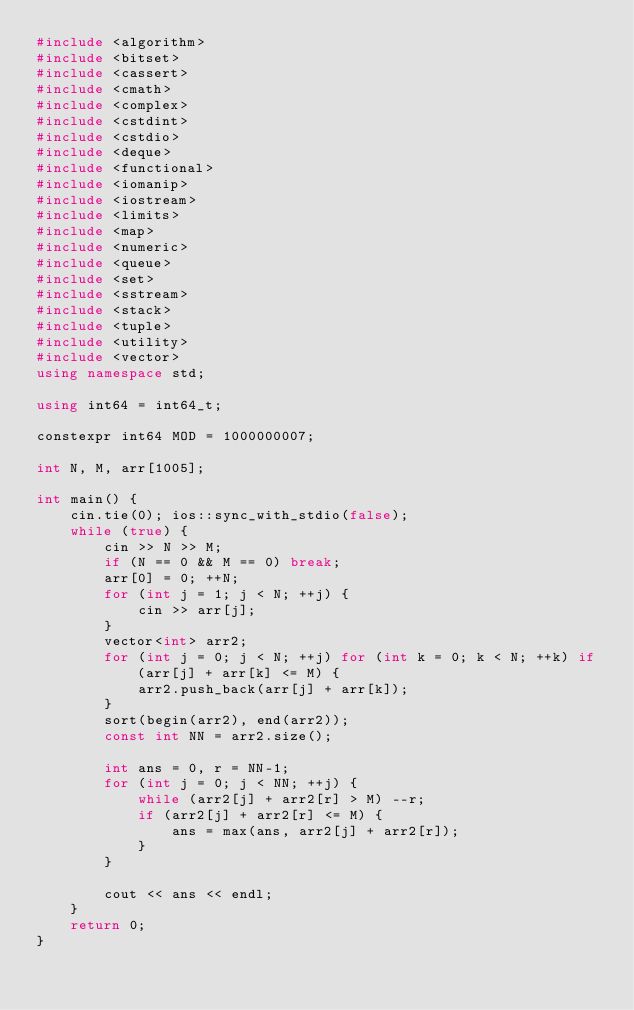Convert code to text. <code><loc_0><loc_0><loc_500><loc_500><_C++_>#include <algorithm>
#include <bitset>
#include <cassert>
#include <cmath>
#include <complex>
#include <cstdint>
#include <cstdio>
#include <deque>
#include <functional>
#include <iomanip>
#include <iostream>
#include <limits>
#include <map>
#include <numeric>
#include <queue>
#include <set>
#include <sstream>
#include <stack>
#include <tuple>
#include <utility>
#include <vector>
using namespace std;

using int64 = int64_t;

constexpr int64 MOD = 1000000007;

int N, M, arr[1005];

int main() {
    cin.tie(0); ios::sync_with_stdio(false);
    while (true) {
        cin >> N >> M;
        if (N == 0 && M == 0) break;
        arr[0] = 0; ++N;
        for (int j = 1; j < N; ++j) {
            cin >> arr[j];
        }
        vector<int> arr2;
        for (int j = 0; j < N; ++j) for (int k = 0; k < N; ++k) if (arr[j] + arr[k] <= M) {
            arr2.push_back(arr[j] + arr[k]);
        }
        sort(begin(arr2), end(arr2));
        const int NN = arr2.size();

        int ans = 0, r = NN-1;
        for (int j = 0; j < NN; ++j) {
            while (arr2[j] + arr2[r] > M) --r;
            if (arr2[j] + arr2[r] <= M) {
                ans = max(ans, arr2[j] + arr2[r]);
            }
        }

        cout << ans << endl;
    }
    return 0;
}</code> 